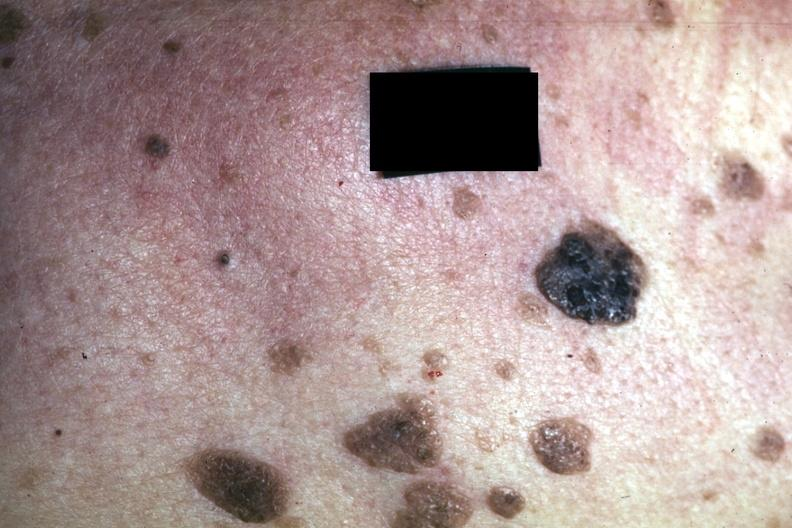s hypopharyngeal edema present?
Answer the question using a single word or phrase. No 